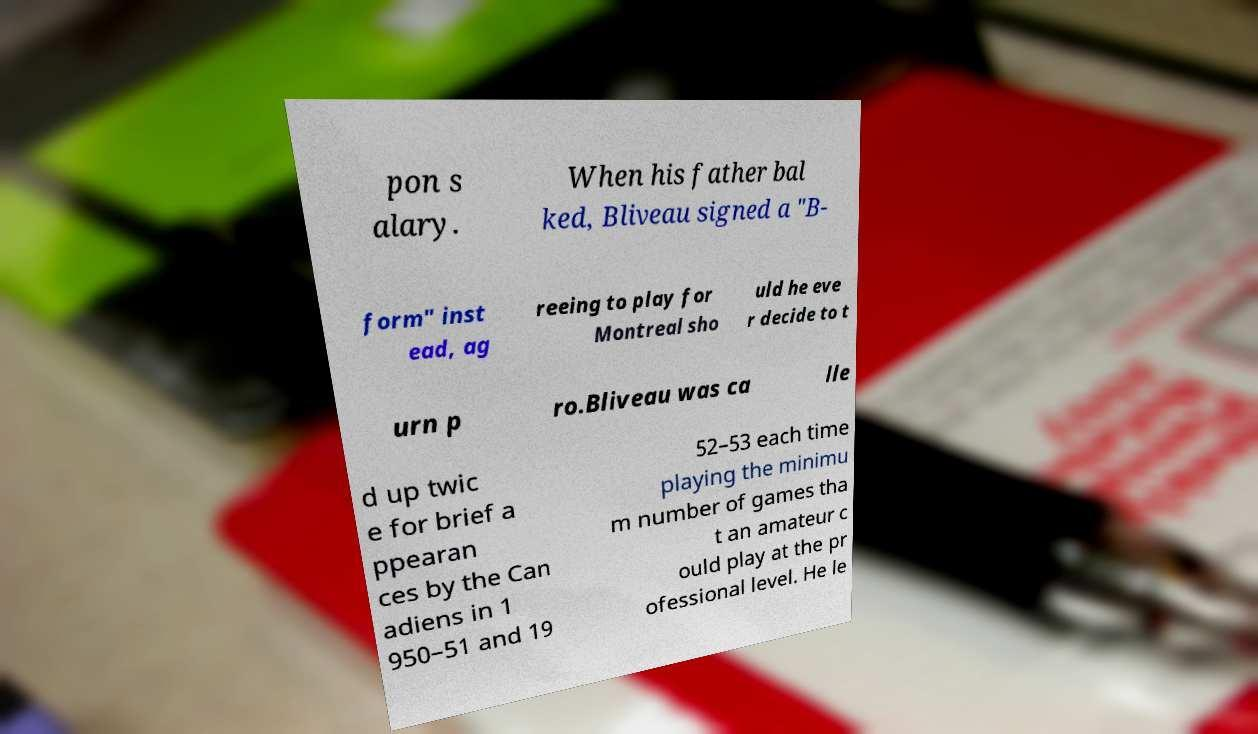There's text embedded in this image that I need extracted. Can you transcribe it verbatim? pon s alary. When his father bal ked, Bliveau signed a "B- form" inst ead, ag reeing to play for Montreal sho uld he eve r decide to t urn p ro.Bliveau was ca lle d up twic e for brief a ppearan ces by the Can adiens in 1 950–51 and 19 52–53 each time playing the minimu m number of games tha t an amateur c ould play at the pr ofessional level. He le 